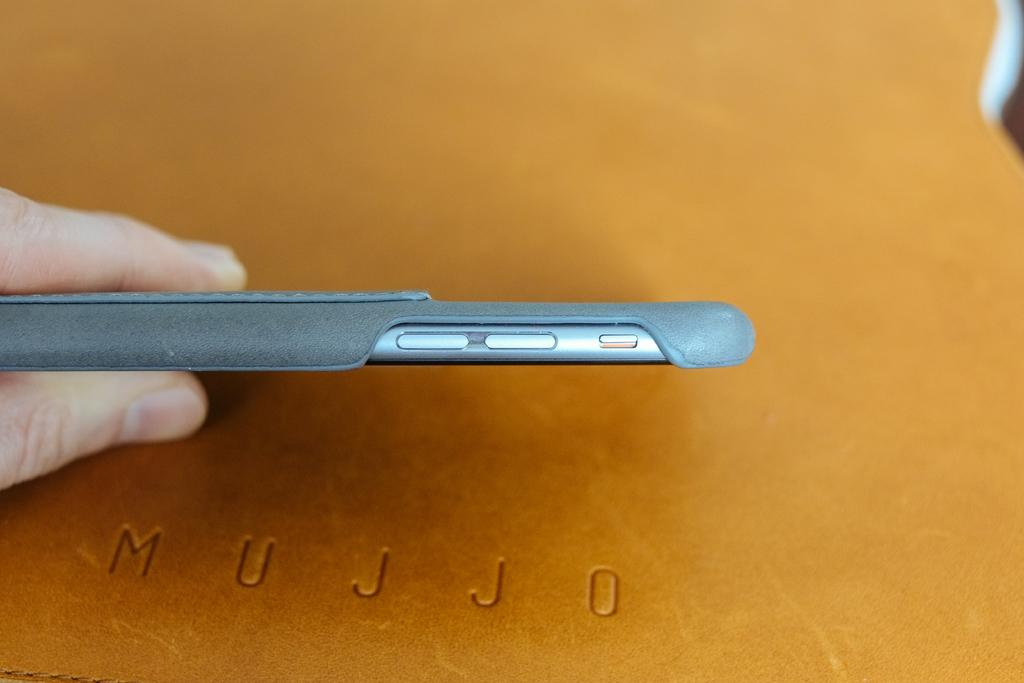<image>
Render a clear and concise summary of the photo. A person holds a phone above an engraved surface that says MUJJO. 